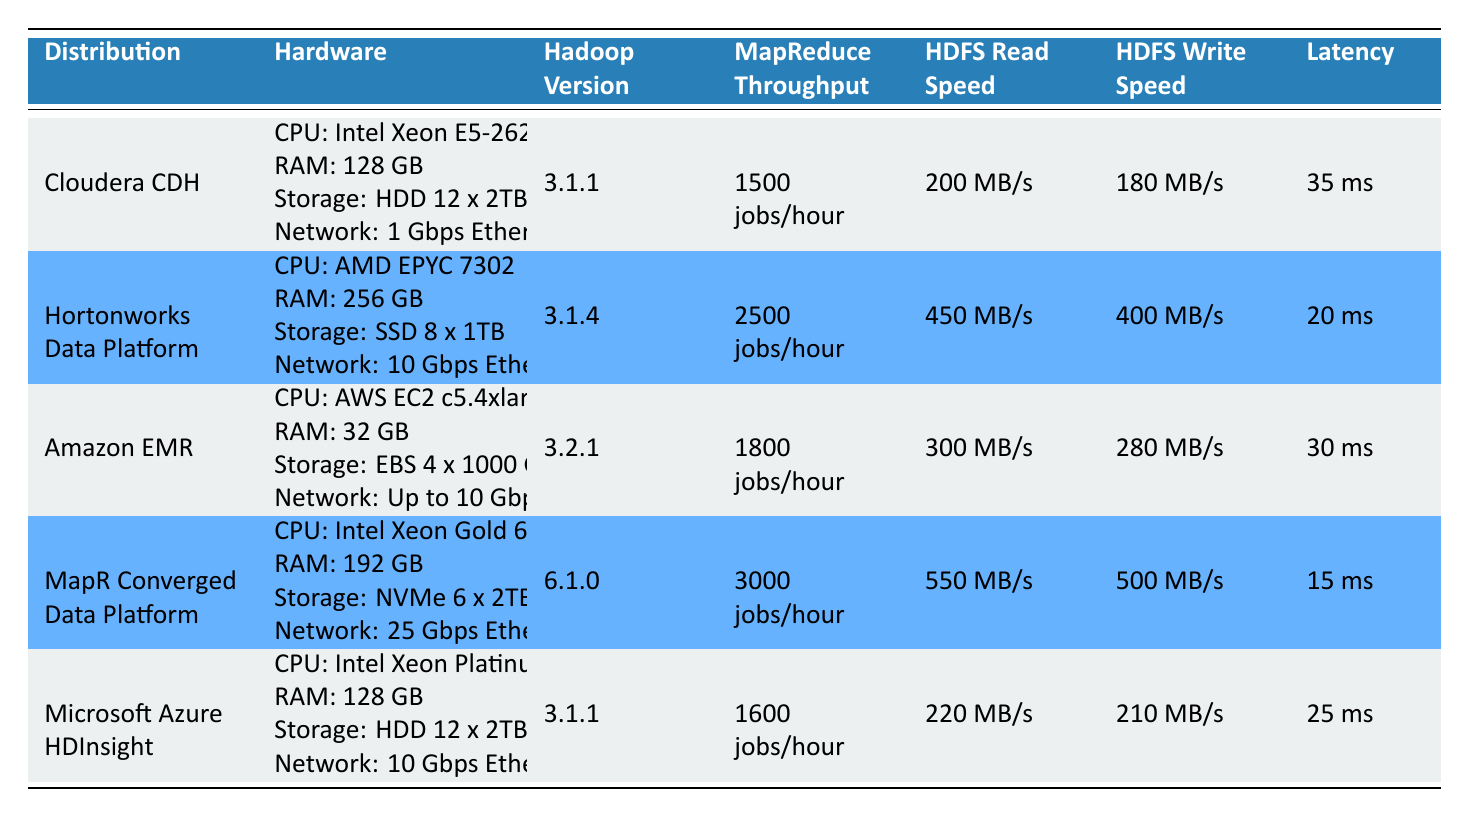What is the Hadoop version for MapR Converged Data Platform? Referring to the table, under the "MapR Converged Data Platform" row, the "Hadoop Version" column shows the version as 6.1.0.
Answer: 6.1.0 Which distribution has the highest HDFS Write Speed? By comparing the "HDFS Write Speed" values in the table, the highest value is 500 MB/s for the MapR Converged Data Platform.
Answer: MapR Converged Data Platform What is the average MapReduce Throughput of all distributions? To find the average, we sum the MapReduce Throughput values: 1500 + 2500 + 1800 + 3000 + 1600 = 10400 jobs/hour. There are 5 distributions, so the average is 10400/5 = 2080 jobs/hour.
Answer: 2080 jobs/hour Does Hortonworks Data Platform have a lower latency than Microsoft Azure HDInsight? Examining the latencies, Hortonworks has 20 ms while Microsoft Azure HDInsight has 25 ms. Since 20 ms is less than 25 ms, the statement is true.
Answer: Yes Which distribution has the lowest HDFS Read Speed? Looking at the HDFS Read Speed column, Amazon EMR has the lowest value of 300 MB/s compared to other distributions.
Answer: Amazon EMR How much faster is the HDFS Read Speed of MapR Converged Data Platform compared to Cloudera CDH? The HDFS Read Speed for MapR is 550 MB/s, and for Cloudera CDH, it is 200 MB/s. The difference is 550 - 200 = 350 MB/s, indicating MapR is 350 MB/s faster.
Answer: 350 MB/s Which two distributions yield a total of 6,300 jobs/hour in MapReduce Throughput? By trying different combinations of the MapReduce Throughput values, Hortonworks Data Platform (2500 jobs/hour) and MapR Converged Data Platform (3000 jobs/hour) yield a total of 5500 jobs/hour, which is the closest to 6300, but no pair sums to 6300. Therefore, we conclude there is no valid combination.
Answer: No valid combination What is the storage type used by Amazon EMR? Referring to the Amazon EMR row, it shows "Storage: EBS 4 x 1000 GB" in the "Hardware" section.
Answer: EBS 4 x 1000 GB 